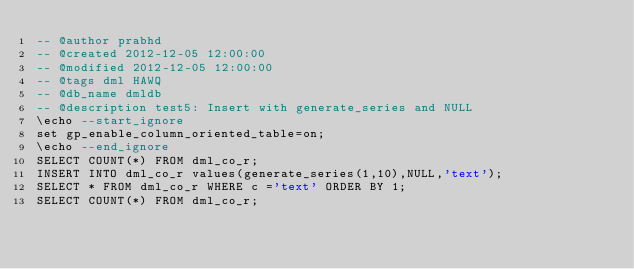Convert code to text. <code><loc_0><loc_0><loc_500><loc_500><_SQL_>-- @author prabhd 
-- @created 2012-12-05 12:00:00 
-- @modified 2012-12-05 12:00:00 
-- @tags dml HAWQ 
-- @db_name dmldb
-- @description test5: Insert with generate_series and NULL
\echo --start_ignore
set gp_enable_column_oriented_table=on;
\echo --end_ignore
SELECT COUNT(*) FROM dml_co_r;
INSERT INTO dml_co_r values(generate_series(1,10),NULL,'text');
SELECT * FROM dml_co_r WHERE c ='text' ORDER BY 1;
SELECT COUNT(*) FROM dml_co_r;
</code> 